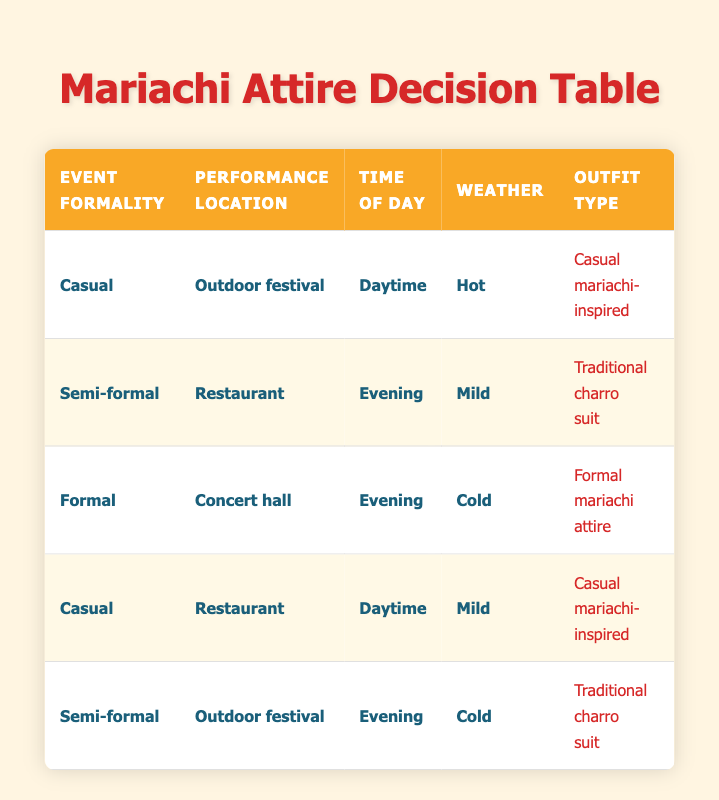What outfit type is suitable for a casual outdoor festival during the daytime in hot weather? In the table, there is a rule for a casual setting during an outdoor festival in the daytime when the weather is hot. The corresponding outfit type in that row is "Casual mariachi-inspired."
Answer: Casual mariachi-inspired What type of accessories are recommended for an evening performance at a restaurant in mild weather? Looking at the second row of the table, which specifies a semi-formal setting at a restaurant in the evening with mild weather, the recommended accessory is "Embroidered sombrero."
Answer: Embroidered sombrero In which performance location is formal mariachi attire suggested? By reviewing the table, the third row indicates that formal mariachi attire is suggested for performances at a concert hall during the evening in cold weather.
Answer: Concert hall Are polished boots recommended for all performance types? Checking the footwear section in the table, polished boots are not recommended in casual settings; they appear only in semi-formal and formal recommendations, indicating that they are not universally suitable.
Answer: No What is the color scheme for a traditional charro suit in a semi-formal outdoor festival during the evening in cold weather? In the table, you can find a row showing a semi-formal setting at an outdoor festival during the evening with cold weather. The associated color scheme is "Black and white" when wearing a traditional charro suit.
Answer: Black and white How many different outfit types are listed for casual performances? The table shows two instances of casual outfit types in the first and fourth rows, which detail "Casual mariachi-inspired" for both scenarios, confirming there is only one type.
Answer: 1 Is there a recommendation for a bolo tie with casual attire? The fourth row indicates a casual setting at a restaurant during daytime in mild weather suggests "Bolo tie" as an accessory, confirming it's a recommended item.
Answer: Yes If a performance is formal and takes place in a concert hall during cold weather, what footwear should be worn? The table specifies that in this scenario, the footwear recommended is "Polished boots," located in the third row.
Answer: Polished boots What are the conditions for wearing bright colors in an outfit? The first row outlines that bright colors are to be worn during a casual outdoor festival in the daytime when the weather is hot, effectively providing the conditions that lead to this color choice.
Answer: Casual, Outdoor festival, Daytime, Hot 